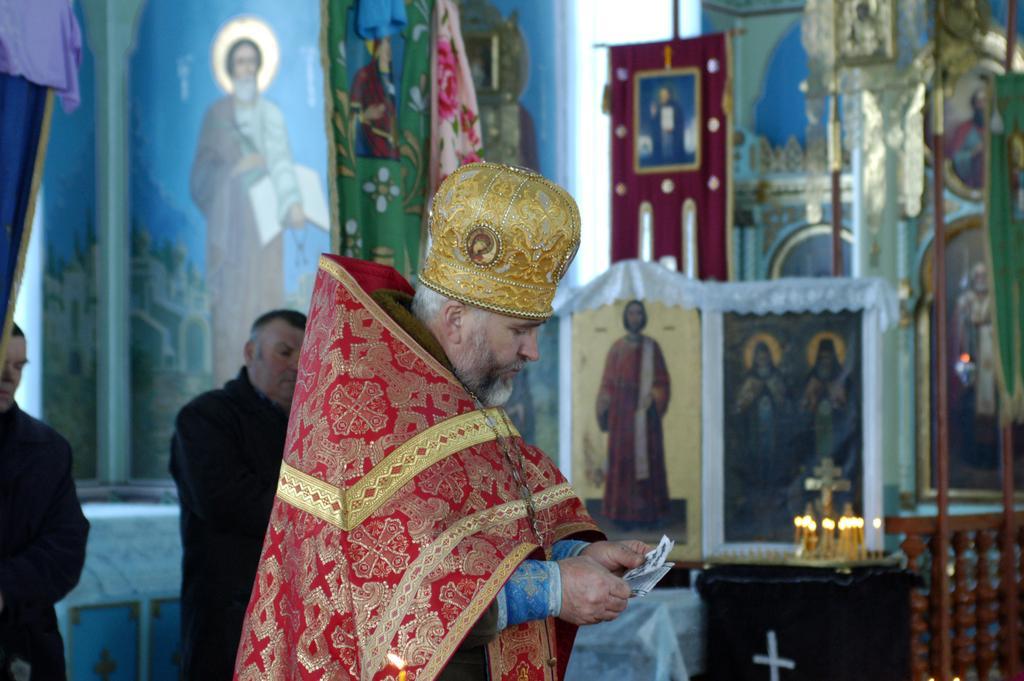Could you give a brief overview of what you see in this image? In the center of the image we can see a priest holding a paper in his hand. On the right there is a table and we can see candles placed on the table. On the left there are two people. In the background there are wall paintings and a board. 